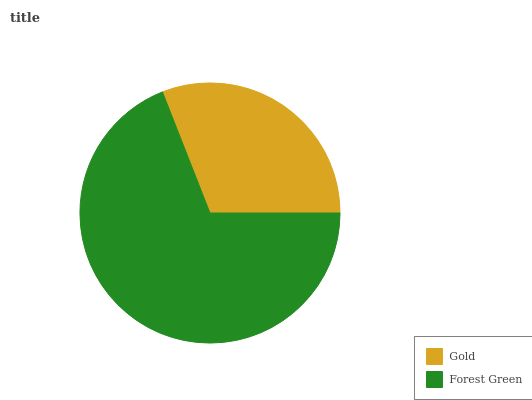Is Gold the minimum?
Answer yes or no. Yes. Is Forest Green the maximum?
Answer yes or no. Yes. Is Forest Green the minimum?
Answer yes or no. No. Is Forest Green greater than Gold?
Answer yes or no. Yes. Is Gold less than Forest Green?
Answer yes or no. Yes. Is Gold greater than Forest Green?
Answer yes or no. No. Is Forest Green less than Gold?
Answer yes or no. No. Is Forest Green the high median?
Answer yes or no. Yes. Is Gold the low median?
Answer yes or no. Yes. Is Gold the high median?
Answer yes or no. No. Is Forest Green the low median?
Answer yes or no. No. 